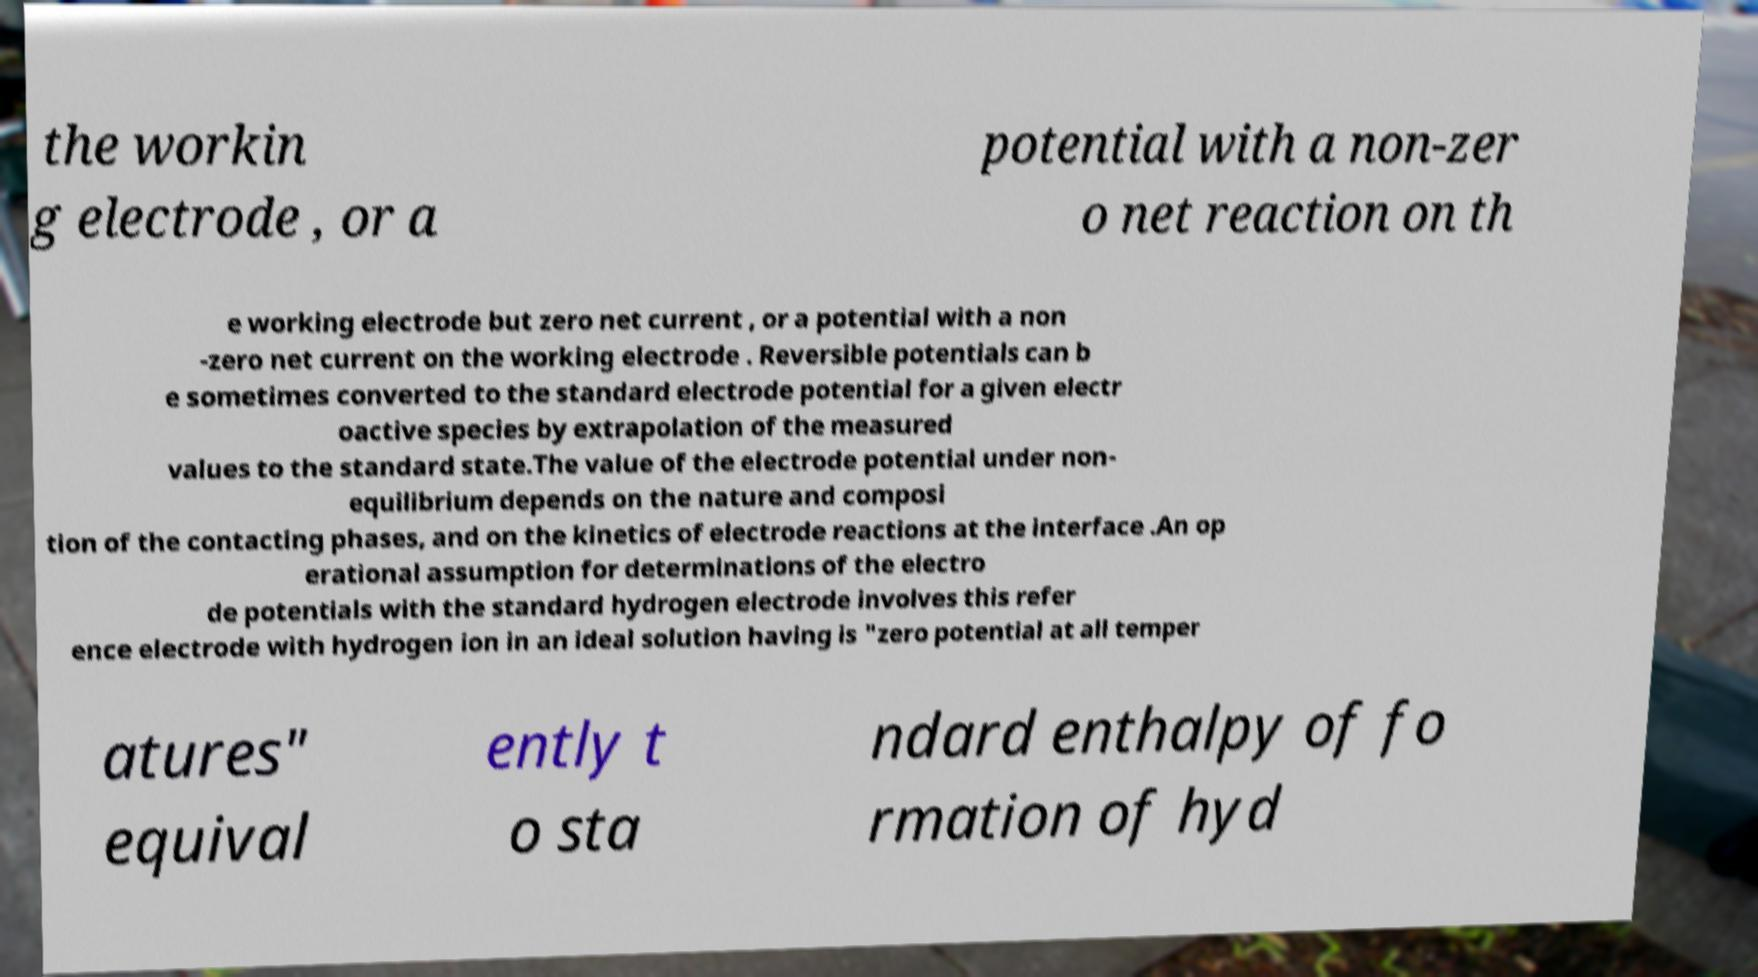Please identify and transcribe the text found in this image. the workin g electrode , or a potential with a non-zer o net reaction on th e working electrode but zero net current , or a potential with a non -zero net current on the working electrode . Reversible potentials can b e sometimes converted to the standard electrode potential for a given electr oactive species by extrapolation of the measured values to the standard state.The value of the electrode potential under non- equilibrium depends on the nature and composi tion of the contacting phases, and on the kinetics of electrode reactions at the interface .An op erational assumption for determinations of the electro de potentials with the standard hydrogen electrode involves this refer ence electrode with hydrogen ion in an ideal solution having is "zero potential at all temper atures" equival ently t o sta ndard enthalpy of fo rmation of hyd 